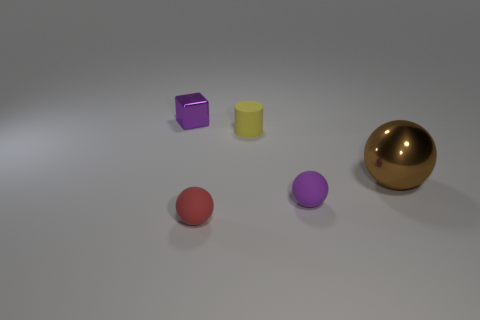Are there any other things that have the same size as the brown metal ball?
Provide a succinct answer. No. What number of cylinders are either tiny metal things or big brown metal things?
Your answer should be very brief. 0. There is another matte thing that is the same shape as the red matte thing; what is its size?
Provide a short and direct response. Small. How many big gray matte cubes are there?
Provide a short and direct response. 0. Is the shape of the large shiny object the same as the purple thing right of the purple cube?
Provide a short and direct response. Yes. What is the size of the metal object to the left of the large metallic thing?
Keep it short and to the point. Small. What is the material of the big brown thing?
Provide a succinct answer. Metal. Is the shape of the small purple object behind the tiny cylinder the same as  the brown metal object?
Your answer should be compact. No. What is the size of the matte ball that is the same color as the cube?
Your answer should be very brief. Small. Is there a brown metallic object that has the same size as the red thing?
Provide a succinct answer. No. 